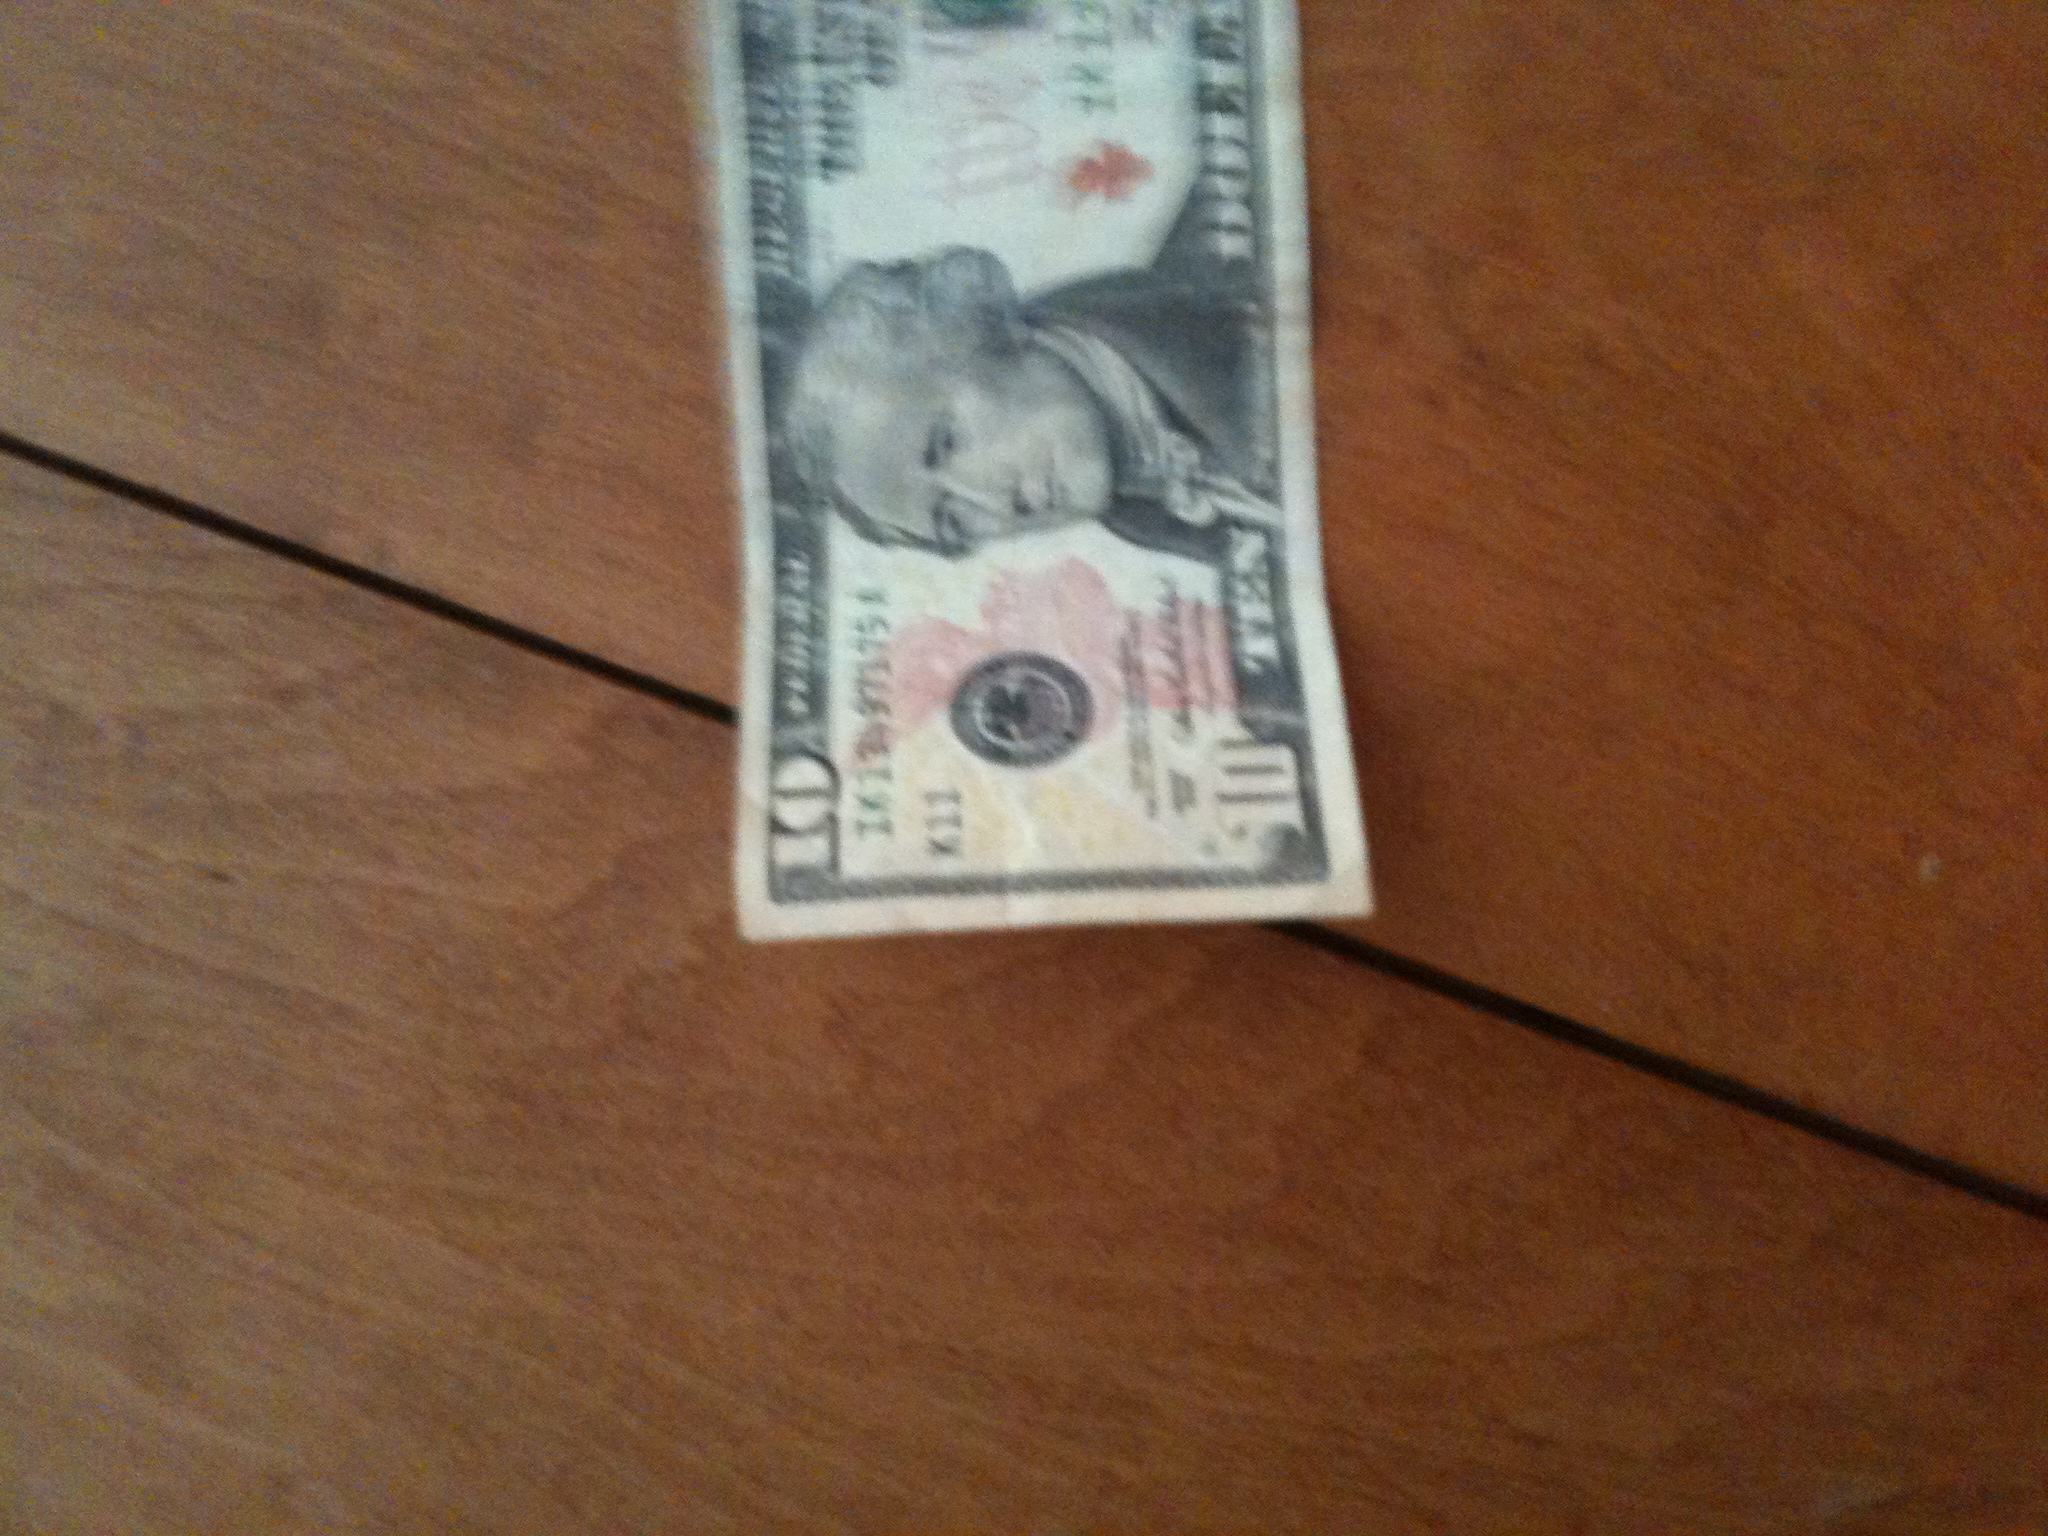this is a 5$ bill The image depicts a 10-dollar bill, clearly indicated by the '10' visible on the bill. 